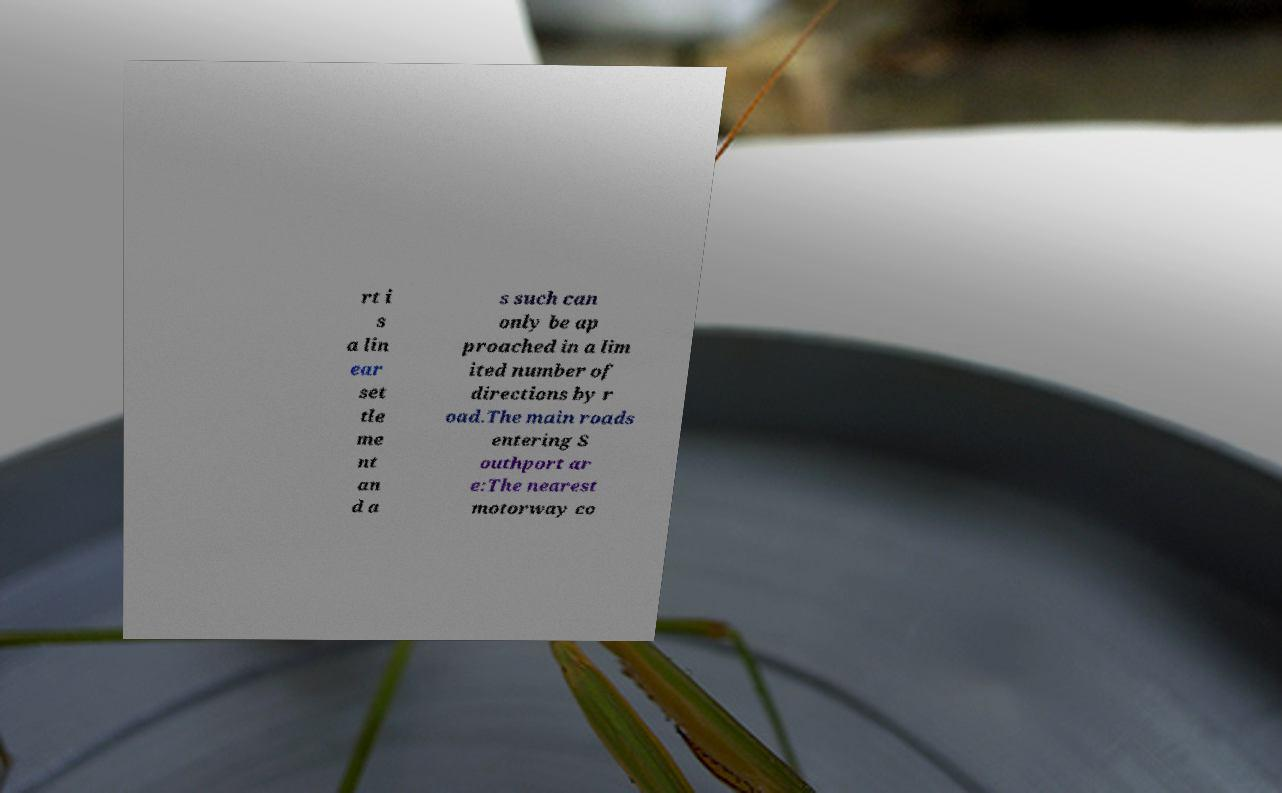Can you accurately transcribe the text from the provided image for me? rt i s a lin ear set tle me nt an d a s such can only be ap proached in a lim ited number of directions by r oad.The main roads entering S outhport ar e:The nearest motorway co 